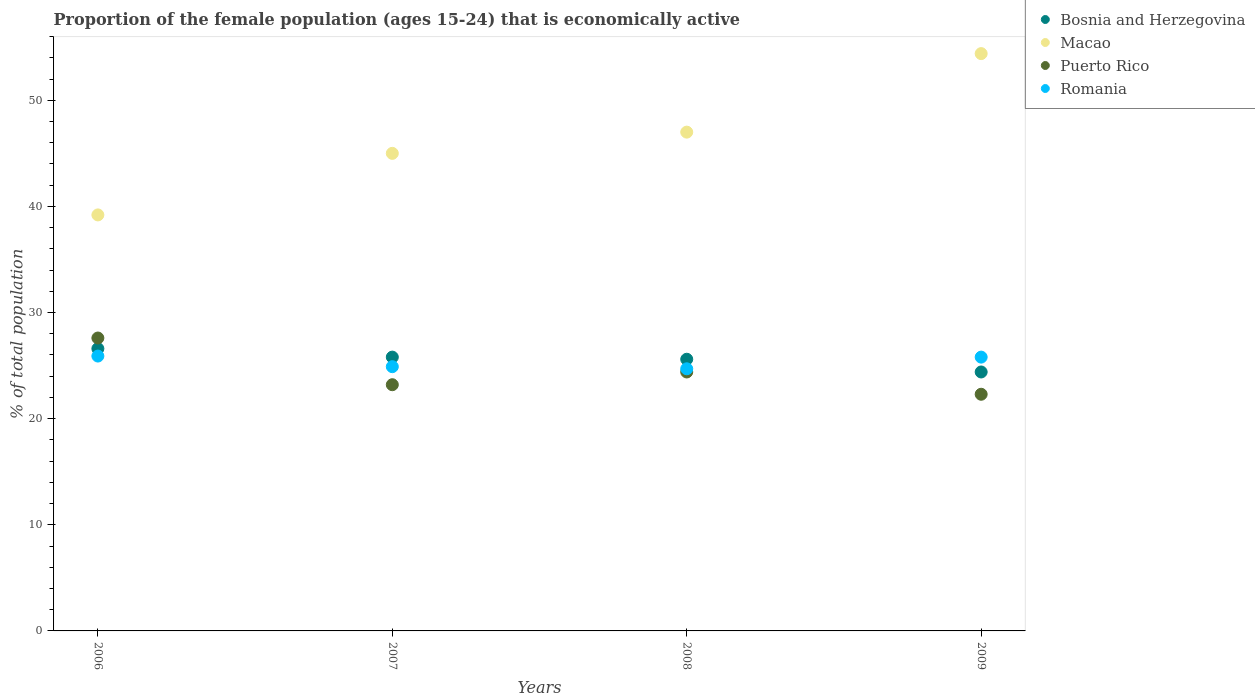What is the proportion of the female population that is economically active in Romania in 2006?
Make the answer very short. 25.9. Across all years, what is the maximum proportion of the female population that is economically active in Romania?
Offer a terse response. 25.9. Across all years, what is the minimum proportion of the female population that is economically active in Puerto Rico?
Your answer should be compact. 22.3. In which year was the proportion of the female population that is economically active in Romania maximum?
Your answer should be very brief. 2006. What is the total proportion of the female population that is economically active in Puerto Rico in the graph?
Make the answer very short. 97.5. What is the difference between the proportion of the female population that is economically active in Macao in 2007 and that in 2009?
Your response must be concise. -9.4. What is the difference between the proportion of the female population that is economically active in Romania in 2009 and the proportion of the female population that is economically active in Puerto Rico in 2008?
Offer a terse response. 1.4. What is the average proportion of the female population that is economically active in Bosnia and Herzegovina per year?
Provide a short and direct response. 25.6. In the year 2007, what is the difference between the proportion of the female population that is economically active in Romania and proportion of the female population that is economically active in Macao?
Your answer should be compact. -20.1. What is the ratio of the proportion of the female population that is economically active in Puerto Rico in 2007 to that in 2008?
Your response must be concise. 0.95. Is the proportion of the female population that is economically active in Puerto Rico in 2008 less than that in 2009?
Provide a short and direct response. No. What is the difference between the highest and the second highest proportion of the female population that is economically active in Puerto Rico?
Your answer should be compact. 3.2. What is the difference between the highest and the lowest proportion of the female population that is economically active in Romania?
Offer a terse response. 1.2. In how many years, is the proportion of the female population that is economically active in Romania greater than the average proportion of the female population that is economically active in Romania taken over all years?
Your answer should be compact. 2. Is the sum of the proportion of the female population that is economically active in Bosnia and Herzegovina in 2006 and 2009 greater than the maximum proportion of the female population that is economically active in Romania across all years?
Keep it short and to the point. Yes. Is it the case that in every year, the sum of the proportion of the female population that is economically active in Bosnia and Herzegovina and proportion of the female population that is economically active in Romania  is greater than the proportion of the female population that is economically active in Puerto Rico?
Provide a succinct answer. Yes. Does the proportion of the female population that is economically active in Romania monotonically increase over the years?
Your answer should be compact. No. Is the proportion of the female population that is economically active in Macao strictly greater than the proportion of the female population that is economically active in Puerto Rico over the years?
Make the answer very short. Yes. Is the proportion of the female population that is economically active in Romania strictly less than the proportion of the female population that is economically active in Bosnia and Herzegovina over the years?
Your answer should be compact. No. Are the values on the major ticks of Y-axis written in scientific E-notation?
Your answer should be compact. No. Does the graph contain any zero values?
Give a very brief answer. No. Does the graph contain grids?
Your answer should be very brief. No. Where does the legend appear in the graph?
Offer a terse response. Top right. What is the title of the graph?
Keep it short and to the point. Proportion of the female population (ages 15-24) that is economically active. Does "United Kingdom" appear as one of the legend labels in the graph?
Provide a succinct answer. No. What is the label or title of the X-axis?
Give a very brief answer. Years. What is the label or title of the Y-axis?
Your answer should be compact. % of total population. What is the % of total population in Bosnia and Herzegovina in 2006?
Offer a terse response. 26.6. What is the % of total population in Macao in 2006?
Keep it short and to the point. 39.2. What is the % of total population in Puerto Rico in 2006?
Offer a very short reply. 27.6. What is the % of total population in Romania in 2006?
Provide a succinct answer. 25.9. What is the % of total population in Bosnia and Herzegovina in 2007?
Your answer should be very brief. 25.8. What is the % of total population in Macao in 2007?
Your response must be concise. 45. What is the % of total population in Puerto Rico in 2007?
Offer a very short reply. 23.2. What is the % of total population of Romania in 2007?
Make the answer very short. 24.9. What is the % of total population of Bosnia and Herzegovina in 2008?
Provide a short and direct response. 25.6. What is the % of total population of Puerto Rico in 2008?
Your answer should be compact. 24.4. What is the % of total population of Romania in 2008?
Provide a short and direct response. 24.7. What is the % of total population in Bosnia and Herzegovina in 2009?
Make the answer very short. 24.4. What is the % of total population in Macao in 2009?
Give a very brief answer. 54.4. What is the % of total population in Puerto Rico in 2009?
Your answer should be compact. 22.3. What is the % of total population in Romania in 2009?
Provide a succinct answer. 25.8. Across all years, what is the maximum % of total population in Bosnia and Herzegovina?
Your answer should be very brief. 26.6. Across all years, what is the maximum % of total population of Macao?
Give a very brief answer. 54.4. Across all years, what is the maximum % of total population of Puerto Rico?
Make the answer very short. 27.6. Across all years, what is the maximum % of total population in Romania?
Provide a short and direct response. 25.9. Across all years, what is the minimum % of total population of Bosnia and Herzegovina?
Provide a short and direct response. 24.4. Across all years, what is the minimum % of total population of Macao?
Give a very brief answer. 39.2. Across all years, what is the minimum % of total population in Puerto Rico?
Your answer should be compact. 22.3. Across all years, what is the minimum % of total population of Romania?
Your response must be concise. 24.7. What is the total % of total population in Bosnia and Herzegovina in the graph?
Offer a terse response. 102.4. What is the total % of total population in Macao in the graph?
Your answer should be very brief. 185.6. What is the total % of total population of Puerto Rico in the graph?
Keep it short and to the point. 97.5. What is the total % of total population of Romania in the graph?
Your answer should be compact. 101.3. What is the difference between the % of total population in Bosnia and Herzegovina in 2006 and that in 2007?
Keep it short and to the point. 0.8. What is the difference between the % of total population in Macao in 2006 and that in 2007?
Offer a terse response. -5.8. What is the difference between the % of total population in Puerto Rico in 2006 and that in 2007?
Your answer should be very brief. 4.4. What is the difference between the % of total population in Romania in 2006 and that in 2007?
Your answer should be very brief. 1. What is the difference between the % of total population in Bosnia and Herzegovina in 2006 and that in 2008?
Your response must be concise. 1. What is the difference between the % of total population in Romania in 2006 and that in 2008?
Keep it short and to the point. 1.2. What is the difference between the % of total population of Macao in 2006 and that in 2009?
Give a very brief answer. -15.2. What is the difference between the % of total population of Puerto Rico in 2006 and that in 2009?
Provide a succinct answer. 5.3. What is the difference between the % of total population of Romania in 2006 and that in 2009?
Offer a very short reply. 0.1. What is the difference between the % of total population of Bosnia and Herzegovina in 2007 and that in 2008?
Your answer should be compact. 0.2. What is the difference between the % of total population of Macao in 2007 and that in 2008?
Ensure brevity in your answer.  -2. What is the difference between the % of total population in Macao in 2007 and that in 2009?
Provide a short and direct response. -9.4. What is the difference between the % of total population of Romania in 2007 and that in 2009?
Your answer should be compact. -0.9. What is the difference between the % of total population in Macao in 2008 and that in 2009?
Offer a terse response. -7.4. What is the difference between the % of total population in Puerto Rico in 2008 and that in 2009?
Your answer should be compact. 2.1. What is the difference between the % of total population of Romania in 2008 and that in 2009?
Your response must be concise. -1.1. What is the difference between the % of total population in Bosnia and Herzegovina in 2006 and the % of total population in Macao in 2007?
Give a very brief answer. -18.4. What is the difference between the % of total population of Bosnia and Herzegovina in 2006 and the % of total population of Puerto Rico in 2007?
Offer a very short reply. 3.4. What is the difference between the % of total population in Bosnia and Herzegovina in 2006 and the % of total population in Romania in 2007?
Your response must be concise. 1.7. What is the difference between the % of total population of Macao in 2006 and the % of total population of Puerto Rico in 2007?
Provide a short and direct response. 16. What is the difference between the % of total population of Macao in 2006 and the % of total population of Romania in 2007?
Offer a very short reply. 14.3. What is the difference between the % of total population of Bosnia and Herzegovina in 2006 and the % of total population of Macao in 2008?
Ensure brevity in your answer.  -20.4. What is the difference between the % of total population in Bosnia and Herzegovina in 2006 and the % of total population in Puerto Rico in 2008?
Provide a succinct answer. 2.2. What is the difference between the % of total population of Macao in 2006 and the % of total population of Puerto Rico in 2008?
Keep it short and to the point. 14.8. What is the difference between the % of total population of Bosnia and Herzegovina in 2006 and the % of total population of Macao in 2009?
Give a very brief answer. -27.8. What is the difference between the % of total population in Macao in 2006 and the % of total population in Puerto Rico in 2009?
Offer a terse response. 16.9. What is the difference between the % of total population of Macao in 2006 and the % of total population of Romania in 2009?
Your response must be concise. 13.4. What is the difference between the % of total population of Puerto Rico in 2006 and the % of total population of Romania in 2009?
Offer a terse response. 1.8. What is the difference between the % of total population in Bosnia and Herzegovina in 2007 and the % of total population in Macao in 2008?
Provide a short and direct response. -21.2. What is the difference between the % of total population of Bosnia and Herzegovina in 2007 and the % of total population of Puerto Rico in 2008?
Your answer should be very brief. 1.4. What is the difference between the % of total population in Bosnia and Herzegovina in 2007 and the % of total population in Romania in 2008?
Keep it short and to the point. 1.1. What is the difference between the % of total population in Macao in 2007 and the % of total population in Puerto Rico in 2008?
Offer a very short reply. 20.6. What is the difference between the % of total population in Macao in 2007 and the % of total population in Romania in 2008?
Offer a terse response. 20.3. What is the difference between the % of total population of Bosnia and Herzegovina in 2007 and the % of total population of Macao in 2009?
Your response must be concise. -28.6. What is the difference between the % of total population of Bosnia and Herzegovina in 2007 and the % of total population of Romania in 2009?
Your answer should be compact. 0. What is the difference between the % of total population in Macao in 2007 and the % of total population in Puerto Rico in 2009?
Your answer should be very brief. 22.7. What is the difference between the % of total population of Macao in 2007 and the % of total population of Romania in 2009?
Make the answer very short. 19.2. What is the difference between the % of total population of Bosnia and Herzegovina in 2008 and the % of total population of Macao in 2009?
Your answer should be very brief. -28.8. What is the difference between the % of total population of Bosnia and Herzegovina in 2008 and the % of total population of Puerto Rico in 2009?
Give a very brief answer. 3.3. What is the difference between the % of total population in Bosnia and Herzegovina in 2008 and the % of total population in Romania in 2009?
Give a very brief answer. -0.2. What is the difference between the % of total population in Macao in 2008 and the % of total population in Puerto Rico in 2009?
Provide a succinct answer. 24.7. What is the difference between the % of total population in Macao in 2008 and the % of total population in Romania in 2009?
Provide a succinct answer. 21.2. What is the average % of total population in Bosnia and Herzegovina per year?
Provide a short and direct response. 25.6. What is the average % of total population in Macao per year?
Give a very brief answer. 46.4. What is the average % of total population in Puerto Rico per year?
Make the answer very short. 24.38. What is the average % of total population of Romania per year?
Make the answer very short. 25.32. In the year 2006, what is the difference between the % of total population in Macao and % of total population in Romania?
Give a very brief answer. 13.3. In the year 2006, what is the difference between the % of total population of Puerto Rico and % of total population of Romania?
Offer a terse response. 1.7. In the year 2007, what is the difference between the % of total population in Bosnia and Herzegovina and % of total population in Macao?
Keep it short and to the point. -19.2. In the year 2007, what is the difference between the % of total population of Macao and % of total population of Puerto Rico?
Keep it short and to the point. 21.8. In the year 2007, what is the difference between the % of total population in Macao and % of total population in Romania?
Offer a terse response. 20.1. In the year 2008, what is the difference between the % of total population in Bosnia and Herzegovina and % of total population in Macao?
Offer a terse response. -21.4. In the year 2008, what is the difference between the % of total population in Bosnia and Herzegovina and % of total population in Puerto Rico?
Provide a short and direct response. 1.2. In the year 2008, what is the difference between the % of total population in Macao and % of total population in Puerto Rico?
Provide a succinct answer. 22.6. In the year 2008, what is the difference between the % of total population in Macao and % of total population in Romania?
Offer a very short reply. 22.3. In the year 2008, what is the difference between the % of total population in Puerto Rico and % of total population in Romania?
Provide a short and direct response. -0.3. In the year 2009, what is the difference between the % of total population in Bosnia and Herzegovina and % of total population in Puerto Rico?
Offer a terse response. 2.1. In the year 2009, what is the difference between the % of total population of Bosnia and Herzegovina and % of total population of Romania?
Provide a short and direct response. -1.4. In the year 2009, what is the difference between the % of total population in Macao and % of total population in Puerto Rico?
Your answer should be compact. 32.1. In the year 2009, what is the difference between the % of total population in Macao and % of total population in Romania?
Provide a short and direct response. 28.6. In the year 2009, what is the difference between the % of total population in Puerto Rico and % of total population in Romania?
Ensure brevity in your answer.  -3.5. What is the ratio of the % of total population in Bosnia and Herzegovina in 2006 to that in 2007?
Provide a succinct answer. 1.03. What is the ratio of the % of total population of Macao in 2006 to that in 2007?
Ensure brevity in your answer.  0.87. What is the ratio of the % of total population of Puerto Rico in 2006 to that in 2007?
Give a very brief answer. 1.19. What is the ratio of the % of total population in Romania in 2006 to that in 2007?
Offer a terse response. 1.04. What is the ratio of the % of total population in Bosnia and Herzegovina in 2006 to that in 2008?
Your answer should be very brief. 1.04. What is the ratio of the % of total population of Macao in 2006 to that in 2008?
Make the answer very short. 0.83. What is the ratio of the % of total population of Puerto Rico in 2006 to that in 2008?
Your response must be concise. 1.13. What is the ratio of the % of total population in Romania in 2006 to that in 2008?
Keep it short and to the point. 1.05. What is the ratio of the % of total population of Bosnia and Herzegovina in 2006 to that in 2009?
Offer a terse response. 1.09. What is the ratio of the % of total population in Macao in 2006 to that in 2009?
Keep it short and to the point. 0.72. What is the ratio of the % of total population in Puerto Rico in 2006 to that in 2009?
Offer a terse response. 1.24. What is the ratio of the % of total population of Macao in 2007 to that in 2008?
Offer a very short reply. 0.96. What is the ratio of the % of total population of Puerto Rico in 2007 to that in 2008?
Offer a terse response. 0.95. What is the ratio of the % of total population of Bosnia and Herzegovina in 2007 to that in 2009?
Provide a short and direct response. 1.06. What is the ratio of the % of total population in Macao in 2007 to that in 2009?
Your answer should be very brief. 0.83. What is the ratio of the % of total population of Puerto Rico in 2007 to that in 2009?
Your answer should be very brief. 1.04. What is the ratio of the % of total population of Romania in 2007 to that in 2009?
Keep it short and to the point. 0.97. What is the ratio of the % of total population in Bosnia and Herzegovina in 2008 to that in 2009?
Provide a succinct answer. 1.05. What is the ratio of the % of total population in Macao in 2008 to that in 2009?
Your answer should be compact. 0.86. What is the ratio of the % of total population in Puerto Rico in 2008 to that in 2009?
Your answer should be compact. 1.09. What is the ratio of the % of total population in Romania in 2008 to that in 2009?
Keep it short and to the point. 0.96. What is the difference between the highest and the second highest % of total population in Bosnia and Herzegovina?
Offer a very short reply. 0.8. What is the difference between the highest and the second highest % of total population of Macao?
Provide a succinct answer. 7.4. What is the difference between the highest and the second highest % of total population of Romania?
Make the answer very short. 0.1. What is the difference between the highest and the lowest % of total population in Bosnia and Herzegovina?
Keep it short and to the point. 2.2. What is the difference between the highest and the lowest % of total population in Macao?
Keep it short and to the point. 15.2. What is the difference between the highest and the lowest % of total population of Puerto Rico?
Ensure brevity in your answer.  5.3. 